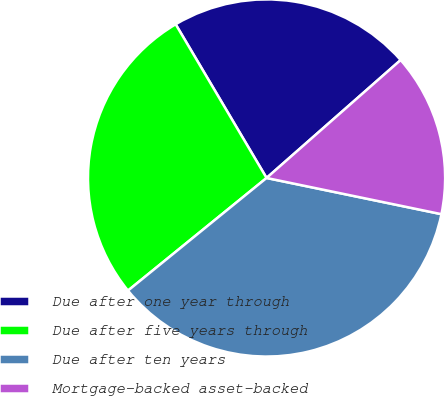Convert chart to OTSL. <chart><loc_0><loc_0><loc_500><loc_500><pie_chart><fcel>Due after one year through<fcel>Due after five years through<fcel>Due after ten years<fcel>Mortgage-backed asset-backed<nl><fcel>22.02%<fcel>27.36%<fcel>35.89%<fcel>14.73%<nl></chart> 